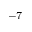Convert formula to latex. <formula><loc_0><loc_0><loc_500><loc_500>^ { - 7 }</formula> 